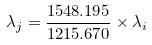<formula> <loc_0><loc_0><loc_500><loc_500>\lambda _ { j } = \frac { 1 5 4 8 . 1 9 5 } { 1 2 1 5 . 6 7 0 } \times \lambda _ { i }</formula> 